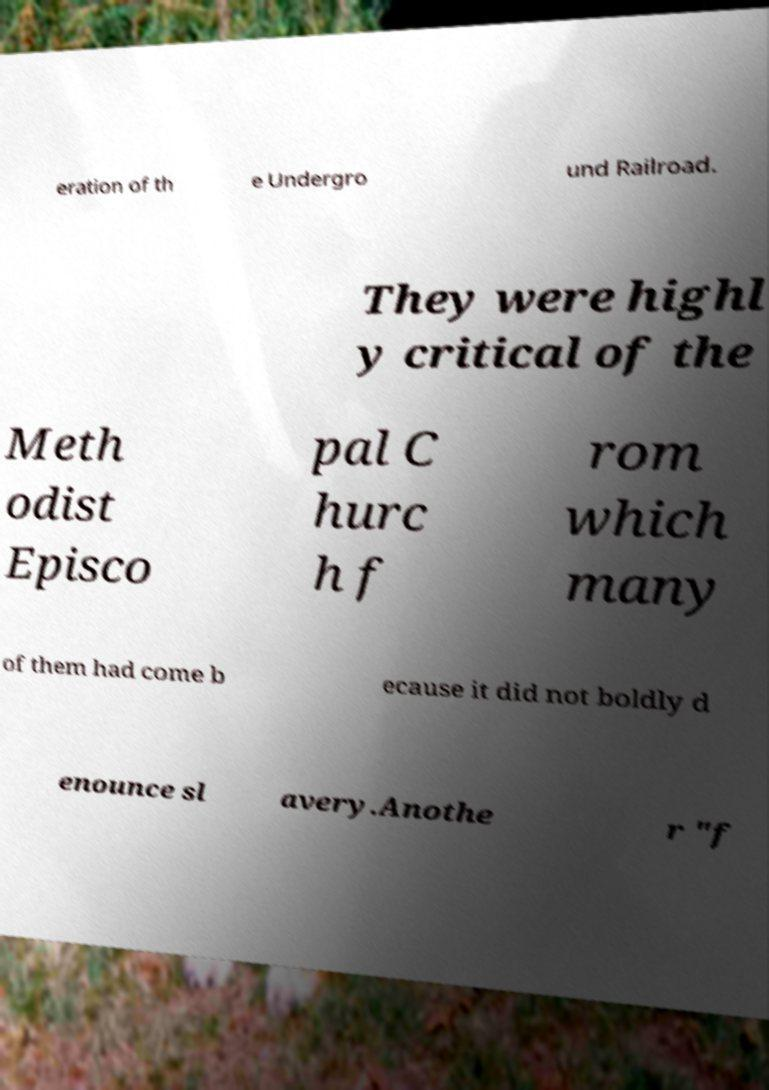Could you extract and type out the text from this image? eration of th e Undergro und Railroad. They were highl y critical of the Meth odist Episco pal C hurc h f rom which many of them had come b ecause it did not boldly d enounce sl avery.Anothe r "f 